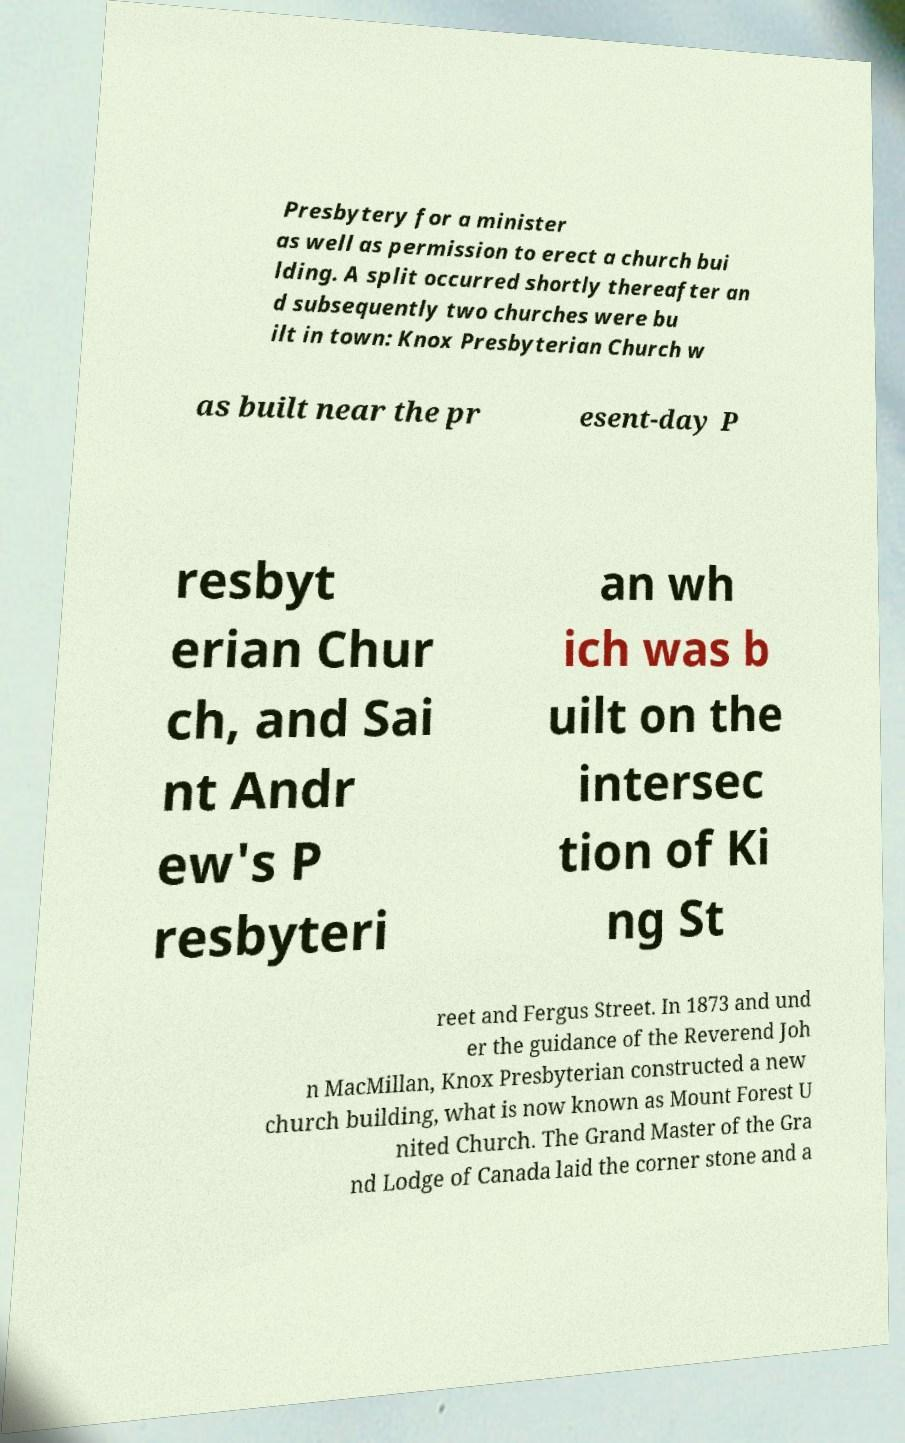I need the written content from this picture converted into text. Can you do that? Presbytery for a minister as well as permission to erect a church bui lding. A split occurred shortly thereafter an d subsequently two churches were bu ilt in town: Knox Presbyterian Church w as built near the pr esent-day P resbyt erian Chur ch, and Sai nt Andr ew's P resbyteri an wh ich was b uilt on the intersec tion of Ki ng St reet and Fergus Street. In 1873 and und er the guidance of the Reverend Joh n MacMillan, Knox Presbyterian constructed a new church building, what is now known as Mount Forest U nited Church. The Grand Master of the Gra nd Lodge of Canada laid the corner stone and a 